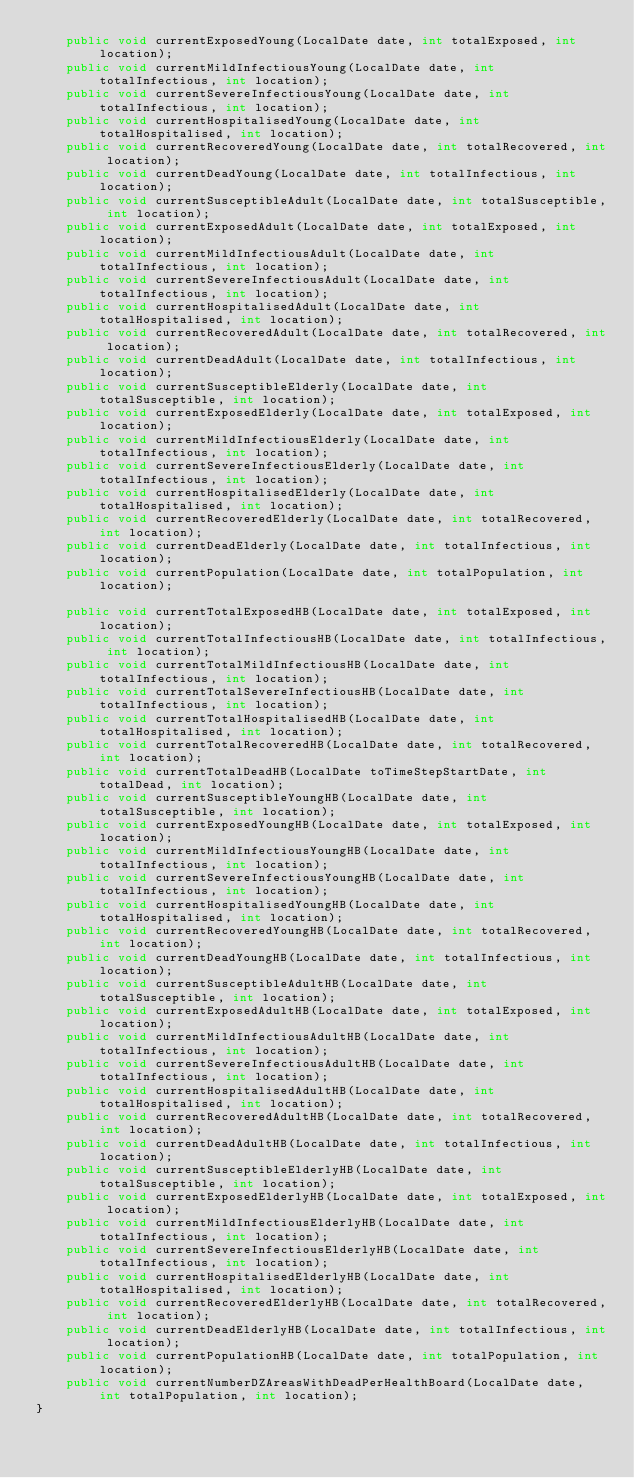Convert code to text. <code><loc_0><loc_0><loc_500><loc_500><_Java_>    public void currentExposedYoung(LocalDate date, int totalExposed, int location);
    public void currentMildInfectiousYoung(LocalDate date, int totalInfectious, int location);
    public void currentSevereInfectiousYoung(LocalDate date, int totalInfectious, int location);
    public void currentHospitalisedYoung(LocalDate date, int totalHospitalised, int location);
    public void currentRecoveredYoung(LocalDate date, int totalRecovered, int location);
    public void currentDeadYoung(LocalDate date, int totalInfectious, int location);
    public void currentSusceptibleAdult(LocalDate date, int totalSusceptible, int location);
    public void currentExposedAdult(LocalDate date, int totalExposed, int location);
    public void currentMildInfectiousAdult(LocalDate date, int totalInfectious, int location);
    public void currentSevereInfectiousAdult(LocalDate date, int totalInfectious, int location);
    public void currentHospitalisedAdult(LocalDate date, int totalHospitalised, int location);
    public void currentRecoveredAdult(LocalDate date, int totalRecovered, int location);
    public void currentDeadAdult(LocalDate date, int totalInfectious, int location);
    public void currentSusceptibleElderly(LocalDate date, int totalSusceptible, int location);
    public void currentExposedElderly(LocalDate date, int totalExposed, int location);
    public void currentMildInfectiousElderly(LocalDate date, int totalInfectious, int location);
    public void currentSevereInfectiousElderly(LocalDate date, int totalInfectious, int location);
    public void currentHospitalisedElderly(LocalDate date, int totalHospitalised, int location);
    public void currentRecoveredElderly(LocalDate date, int totalRecovered, int location);
    public void currentDeadElderly(LocalDate date, int totalInfectious, int location);
    public void currentPopulation(LocalDate date, int totalPopulation, int location);

    public void currentTotalExposedHB(LocalDate date, int totalExposed, int location);
    public void currentTotalInfectiousHB(LocalDate date, int totalInfectious, int location);
    public void currentTotalMildInfectiousHB(LocalDate date, int totalInfectious, int location);
    public void currentTotalSevereInfectiousHB(LocalDate date, int totalInfectious, int location);
    public void currentTotalHospitalisedHB(LocalDate date, int totalHospitalised, int location);
    public void currentTotalRecoveredHB(LocalDate date, int totalRecovered, int location);
    public void currentTotalDeadHB(LocalDate toTimeStepStartDate, int totalDead, int location);
    public void currentSusceptibleYoungHB(LocalDate date, int totalSusceptible, int location);
    public void currentExposedYoungHB(LocalDate date, int totalExposed, int location);
    public void currentMildInfectiousYoungHB(LocalDate date, int totalInfectious, int location);
    public void currentSevereInfectiousYoungHB(LocalDate date, int totalInfectious, int location);
    public void currentHospitalisedYoungHB(LocalDate date, int totalHospitalised, int location);
    public void currentRecoveredYoungHB(LocalDate date, int totalRecovered, int location);
    public void currentDeadYoungHB(LocalDate date, int totalInfectious, int location);
    public void currentSusceptibleAdultHB(LocalDate date, int totalSusceptible, int location);
    public void currentExposedAdultHB(LocalDate date, int totalExposed, int location);
    public void currentMildInfectiousAdultHB(LocalDate date, int totalInfectious, int location);
    public void currentSevereInfectiousAdultHB(LocalDate date, int totalInfectious, int location);
    public void currentHospitalisedAdultHB(LocalDate date, int totalHospitalised, int location);
    public void currentRecoveredAdultHB(LocalDate date, int totalRecovered, int location);
    public void currentDeadAdultHB(LocalDate date, int totalInfectious, int location);
    public void currentSusceptibleElderlyHB(LocalDate date, int totalSusceptible, int location);
    public void currentExposedElderlyHB(LocalDate date, int totalExposed, int location);
    public void currentMildInfectiousElderlyHB(LocalDate date, int totalInfectious, int location);
    public void currentSevereInfectiousElderlyHB(LocalDate date, int totalInfectious, int location);
    public void currentHospitalisedElderlyHB(LocalDate date, int totalHospitalised, int location);
    public void currentRecoveredElderlyHB(LocalDate date, int totalRecovered, int location);
    public void currentDeadElderlyHB(LocalDate date, int totalInfectious, int location);
    public void currentPopulationHB(LocalDate date, int totalPopulation, int location);
    public void currentNumberDZAreasWithDeadPerHealthBoard(LocalDate date, int totalPopulation, int location);
}
</code> 